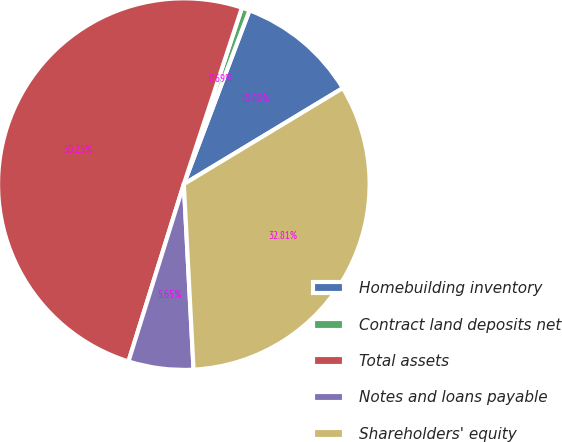Convert chart to OTSL. <chart><loc_0><loc_0><loc_500><loc_500><pie_chart><fcel>Homebuilding inventory<fcel>Contract land deposits net<fcel>Total assets<fcel>Notes and loans payable<fcel>Shareholders' equity<nl><fcel>10.6%<fcel>0.69%<fcel>50.24%<fcel>5.65%<fcel>32.81%<nl></chart> 